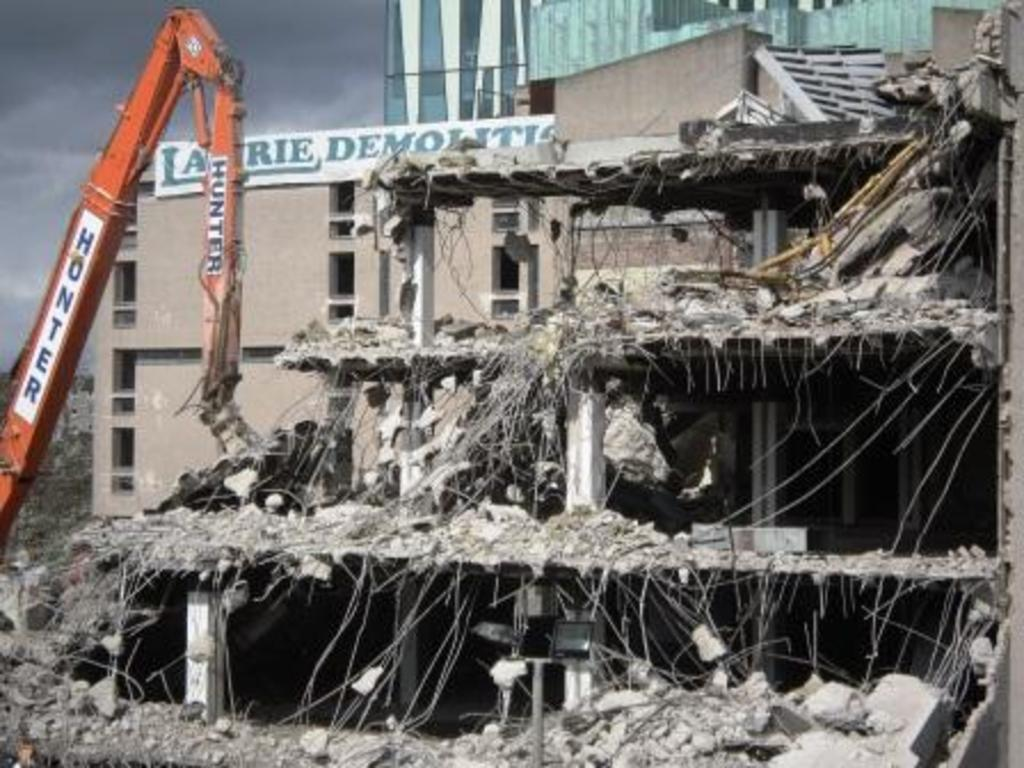What is the main subject of the image? The main subject of the image is a collapsed building. What machinery can be seen on the left side of the image? There is an excavator on the left side of the image. What can be seen in the background of the image? There are buildings, glass, and a hoarding on a building in the background. What is visible in the sky in the image? Clouds are visible in the sky. Where is the hospital located in the image? There is no hospital present in the image. What type of furniture can be seen in the image? There is no furniture present in the image. 